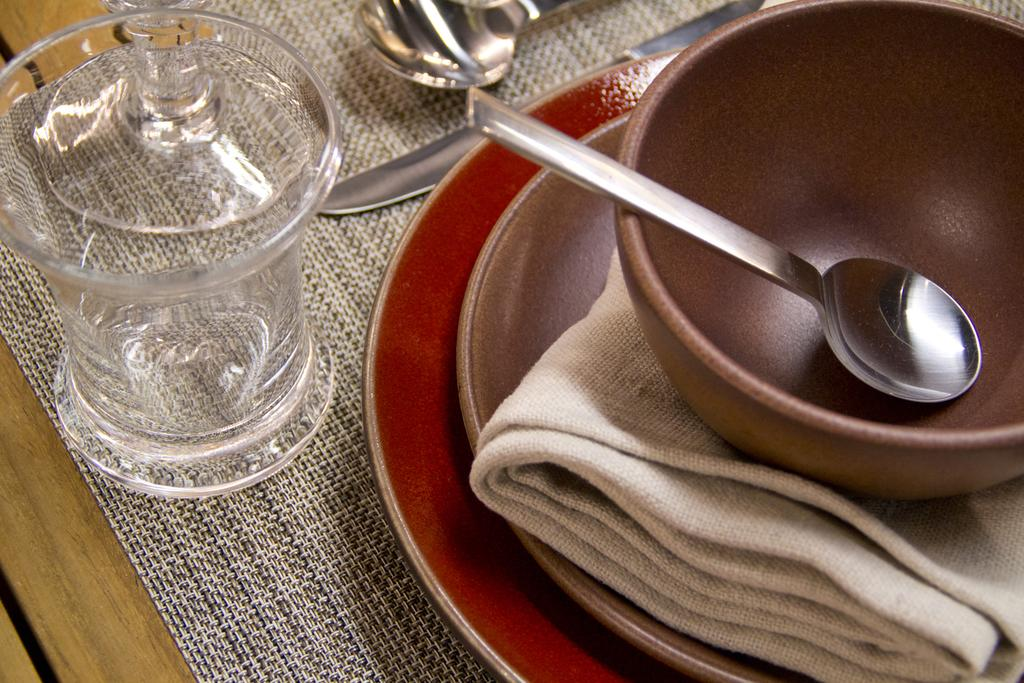What object is located on the left side of the image? There is a glass jar on the left side of the image. What can be seen on the right side of the image? There is a spoon in a bowl on the right side of the image. What utensils are visible at the top of the image? There is a knife and a spoon visible at the top of the image. What type of owl can be seen sitting on the spoon in the image? There is no owl present in the image; it only features a glass jar, a spoon in a bowl, a knife, and another spoon. What is the quince used for in the image? There is no quince present in the image, so it cannot be used for anything. 